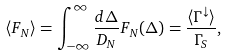Convert formula to latex. <formula><loc_0><loc_0><loc_500><loc_500>\langle F _ { N } \rangle = \int _ { - \infty } ^ { \infty } \frac { d \Delta } { D _ { N } } F _ { N } ( \Delta ) = \frac { \langle \Gamma ^ { \downarrow } \rangle } { \Gamma _ { S } } ,</formula> 